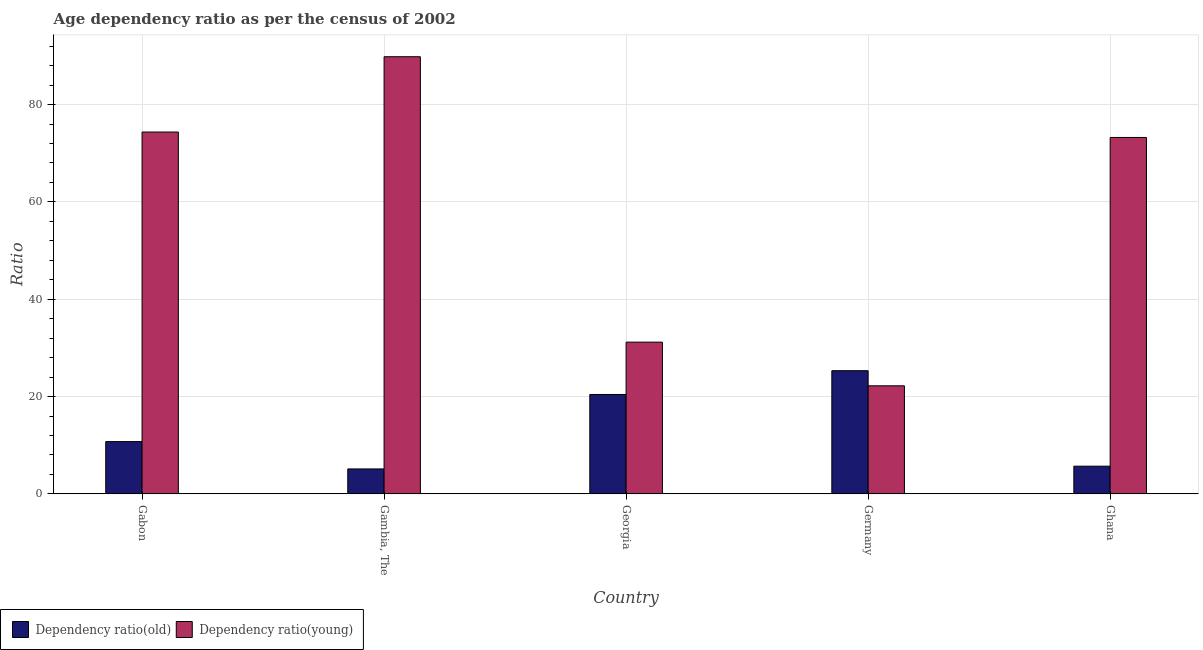How many different coloured bars are there?
Your response must be concise. 2. Are the number of bars on each tick of the X-axis equal?
Provide a succinct answer. Yes. How many bars are there on the 1st tick from the right?
Give a very brief answer. 2. What is the label of the 1st group of bars from the left?
Provide a succinct answer. Gabon. What is the age dependency ratio(young) in Gambia, The?
Make the answer very short. 89.84. Across all countries, what is the maximum age dependency ratio(young)?
Provide a succinct answer. 89.84. Across all countries, what is the minimum age dependency ratio(young)?
Offer a very short reply. 22.21. In which country was the age dependency ratio(young) maximum?
Provide a short and direct response. Gambia, The. In which country was the age dependency ratio(young) minimum?
Give a very brief answer. Germany. What is the total age dependency ratio(young) in the graph?
Make the answer very short. 290.82. What is the difference between the age dependency ratio(old) in Gambia, The and that in Ghana?
Provide a succinct answer. -0.57. What is the difference between the age dependency ratio(old) in Ghana and the age dependency ratio(young) in Georgia?
Your answer should be compact. -25.49. What is the average age dependency ratio(young) per country?
Ensure brevity in your answer.  58.16. What is the difference between the age dependency ratio(young) and age dependency ratio(old) in Ghana?
Ensure brevity in your answer.  67.55. In how many countries, is the age dependency ratio(young) greater than 44 ?
Give a very brief answer. 3. What is the ratio of the age dependency ratio(old) in Gabon to that in Georgia?
Provide a succinct answer. 0.53. Is the age dependency ratio(old) in Gabon less than that in Georgia?
Keep it short and to the point. Yes. Is the difference between the age dependency ratio(young) in Gabon and Gambia, The greater than the difference between the age dependency ratio(old) in Gabon and Gambia, The?
Your response must be concise. No. What is the difference between the highest and the second highest age dependency ratio(old)?
Make the answer very short. 4.89. What is the difference between the highest and the lowest age dependency ratio(old)?
Offer a very short reply. 20.19. In how many countries, is the age dependency ratio(old) greater than the average age dependency ratio(old) taken over all countries?
Provide a succinct answer. 2. Is the sum of the age dependency ratio(old) in Gabon and Germany greater than the maximum age dependency ratio(young) across all countries?
Make the answer very short. No. What does the 2nd bar from the left in Georgia represents?
Your answer should be very brief. Dependency ratio(young). What does the 2nd bar from the right in Gambia, The represents?
Keep it short and to the point. Dependency ratio(old). How many bars are there?
Offer a terse response. 10. How many countries are there in the graph?
Give a very brief answer. 5. What is the difference between two consecutive major ticks on the Y-axis?
Your answer should be compact. 20. What is the title of the graph?
Keep it short and to the point. Age dependency ratio as per the census of 2002. Does "GDP at market prices" appear as one of the legend labels in the graph?
Give a very brief answer. No. What is the label or title of the Y-axis?
Your answer should be very brief. Ratio. What is the Ratio of Dependency ratio(old) in Gabon?
Your answer should be very brief. 10.74. What is the Ratio of Dependency ratio(young) in Gabon?
Provide a succinct answer. 74.36. What is the Ratio in Dependency ratio(old) in Gambia, The?
Your response must be concise. 5.12. What is the Ratio in Dependency ratio(young) in Gambia, The?
Your answer should be compact. 89.84. What is the Ratio of Dependency ratio(old) in Georgia?
Your answer should be compact. 20.42. What is the Ratio of Dependency ratio(young) in Georgia?
Keep it short and to the point. 31.18. What is the Ratio in Dependency ratio(old) in Germany?
Give a very brief answer. 25.31. What is the Ratio in Dependency ratio(young) in Germany?
Offer a terse response. 22.21. What is the Ratio in Dependency ratio(old) in Ghana?
Offer a terse response. 5.69. What is the Ratio in Dependency ratio(young) in Ghana?
Give a very brief answer. 73.24. Across all countries, what is the maximum Ratio in Dependency ratio(old)?
Keep it short and to the point. 25.31. Across all countries, what is the maximum Ratio in Dependency ratio(young)?
Provide a short and direct response. 89.84. Across all countries, what is the minimum Ratio in Dependency ratio(old)?
Provide a short and direct response. 5.12. Across all countries, what is the minimum Ratio of Dependency ratio(young)?
Your answer should be very brief. 22.21. What is the total Ratio of Dependency ratio(old) in the graph?
Give a very brief answer. 67.29. What is the total Ratio in Dependency ratio(young) in the graph?
Your response must be concise. 290.82. What is the difference between the Ratio of Dependency ratio(old) in Gabon and that in Gambia, The?
Ensure brevity in your answer.  5.62. What is the difference between the Ratio in Dependency ratio(young) in Gabon and that in Gambia, The?
Ensure brevity in your answer.  -15.48. What is the difference between the Ratio of Dependency ratio(old) in Gabon and that in Georgia?
Offer a terse response. -9.68. What is the difference between the Ratio in Dependency ratio(young) in Gabon and that in Georgia?
Offer a terse response. 43.18. What is the difference between the Ratio in Dependency ratio(old) in Gabon and that in Germany?
Provide a succinct answer. -14.57. What is the difference between the Ratio of Dependency ratio(young) in Gabon and that in Germany?
Provide a short and direct response. 52.15. What is the difference between the Ratio of Dependency ratio(old) in Gabon and that in Ghana?
Your answer should be compact. 5.06. What is the difference between the Ratio of Dependency ratio(young) in Gabon and that in Ghana?
Offer a terse response. 1.12. What is the difference between the Ratio in Dependency ratio(old) in Gambia, The and that in Georgia?
Offer a very short reply. -15.3. What is the difference between the Ratio of Dependency ratio(young) in Gambia, The and that in Georgia?
Offer a very short reply. 58.66. What is the difference between the Ratio of Dependency ratio(old) in Gambia, The and that in Germany?
Ensure brevity in your answer.  -20.19. What is the difference between the Ratio in Dependency ratio(young) in Gambia, The and that in Germany?
Offer a terse response. 67.63. What is the difference between the Ratio in Dependency ratio(old) in Gambia, The and that in Ghana?
Your answer should be very brief. -0.57. What is the difference between the Ratio in Dependency ratio(young) in Gambia, The and that in Ghana?
Provide a succinct answer. 16.59. What is the difference between the Ratio of Dependency ratio(old) in Georgia and that in Germany?
Your answer should be compact. -4.89. What is the difference between the Ratio of Dependency ratio(young) in Georgia and that in Germany?
Ensure brevity in your answer.  8.97. What is the difference between the Ratio of Dependency ratio(old) in Georgia and that in Ghana?
Your response must be concise. 14.74. What is the difference between the Ratio in Dependency ratio(young) in Georgia and that in Ghana?
Your answer should be very brief. -42.06. What is the difference between the Ratio in Dependency ratio(old) in Germany and that in Ghana?
Ensure brevity in your answer.  19.62. What is the difference between the Ratio of Dependency ratio(young) in Germany and that in Ghana?
Make the answer very short. -51.04. What is the difference between the Ratio in Dependency ratio(old) in Gabon and the Ratio in Dependency ratio(young) in Gambia, The?
Offer a very short reply. -79.09. What is the difference between the Ratio of Dependency ratio(old) in Gabon and the Ratio of Dependency ratio(young) in Georgia?
Make the answer very short. -20.43. What is the difference between the Ratio in Dependency ratio(old) in Gabon and the Ratio in Dependency ratio(young) in Germany?
Offer a very short reply. -11.46. What is the difference between the Ratio of Dependency ratio(old) in Gabon and the Ratio of Dependency ratio(young) in Ghana?
Your answer should be very brief. -62.5. What is the difference between the Ratio of Dependency ratio(old) in Gambia, The and the Ratio of Dependency ratio(young) in Georgia?
Your answer should be very brief. -26.05. What is the difference between the Ratio in Dependency ratio(old) in Gambia, The and the Ratio in Dependency ratio(young) in Germany?
Your answer should be compact. -17.08. What is the difference between the Ratio in Dependency ratio(old) in Gambia, The and the Ratio in Dependency ratio(young) in Ghana?
Keep it short and to the point. -68.12. What is the difference between the Ratio in Dependency ratio(old) in Georgia and the Ratio in Dependency ratio(young) in Germany?
Provide a succinct answer. -1.78. What is the difference between the Ratio of Dependency ratio(old) in Georgia and the Ratio of Dependency ratio(young) in Ghana?
Offer a terse response. -52.82. What is the difference between the Ratio in Dependency ratio(old) in Germany and the Ratio in Dependency ratio(young) in Ghana?
Your answer should be compact. -47.93. What is the average Ratio of Dependency ratio(old) per country?
Keep it short and to the point. 13.46. What is the average Ratio in Dependency ratio(young) per country?
Ensure brevity in your answer.  58.16. What is the difference between the Ratio of Dependency ratio(old) and Ratio of Dependency ratio(young) in Gabon?
Ensure brevity in your answer.  -63.62. What is the difference between the Ratio of Dependency ratio(old) and Ratio of Dependency ratio(young) in Gambia, The?
Your answer should be compact. -84.71. What is the difference between the Ratio of Dependency ratio(old) and Ratio of Dependency ratio(young) in Georgia?
Your response must be concise. -10.75. What is the difference between the Ratio in Dependency ratio(old) and Ratio in Dependency ratio(young) in Germany?
Your response must be concise. 3.1. What is the difference between the Ratio of Dependency ratio(old) and Ratio of Dependency ratio(young) in Ghana?
Provide a short and direct response. -67.55. What is the ratio of the Ratio in Dependency ratio(old) in Gabon to that in Gambia, The?
Make the answer very short. 2.1. What is the ratio of the Ratio of Dependency ratio(young) in Gabon to that in Gambia, The?
Your answer should be very brief. 0.83. What is the ratio of the Ratio of Dependency ratio(old) in Gabon to that in Georgia?
Your answer should be compact. 0.53. What is the ratio of the Ratio in Dependency ratio(young) in Gabon to that in Georgia?
Offer a terse response. 2.38. What is the ratio of the Ratio of Dependency ratio(old) in Gabon to that in Germany?
Provide a succinct answer. 0.42. What is the ratio of the Ratio of Dependency ratio(young) in Gabon to that in Germany?
Offer a very short reply. 3.35. What is the ratio of the Ratio in Dependency ratio(old) in Gabon to that in Ghana?
Offer a terse response. 1.89. What is the ratio of the Ratio of Dependency ratio(young) in Gabon to that in Ghana?
Offer a terse response. 1.02. What is the ratio of the Ratio of Dependency ratio(old) in Gambia, The to that in Georgia?
Your response must be concise. 0.25. What is the ratio of the Ratio of Dependency ratio(young) in Gambia, The to that in Georgia?
Make the answer very short. 2.88. What is the ratio of the Ratio of Dependency ratio(old) in Gambia, The to that in Germany?
Your response must be concise. 0.2. What is the ratio of the Ratio of Dependency ratio(young) in Gambia, The to that in Germany?
Make the answer very short. 4.05. What is the ratio of the Ratio in Dependency ratio(old) in Gambia, The to that in Ghana?
Make the answer very short. 0.9. What is the ratio of the Ratio of Dependency ratio(young) in Gambia, The to that in Ghana?
Provide a succinct answer. 1.23. What is the ratio of the Ratio of Dependency ratio(old) in Georgia to that in Germany?
Keep it short and to the point. 0.81. What is the ratio of the Ratio of Dependency ratio(young) in Georgia to that in Germany?
Keep it short and to the point. 1.4. What is the ratio of the Ratio in Dependency ratio(old) in Georgia to that in Ghana?
Offer a terse response. 3.59. What is the ratio of the Ratio in Dependency ratio(young) in Georgia to that in Ghana?
Keep it short and to the point. 0.43. What is the ratio of the Ratio of Dependency ratio(old) in Germany to that in Ghana?
Give a very brief answer. 4.45. What is the ratio of the Ratio in Dependency ratio(young) in Germany to that in Ghana?
Offer a very short reply. 0.3. What is the difference between the highest and the second highest Ratio in Dependency ratio(old)?
Your answer should be compact. 4.89. What is the difference between the highest and the second highest Ratio in Dependency ratio(young)?
Offer a very short reply. 15.48. What is the difference between the highest and the lowest Ratio in Dependency ratio(old)?
Your response must be concise. 20.19. What is the difference between the highest and the lowest Ratio of Dependency ratio(young)?
Offer a very short reply. 67.63. 